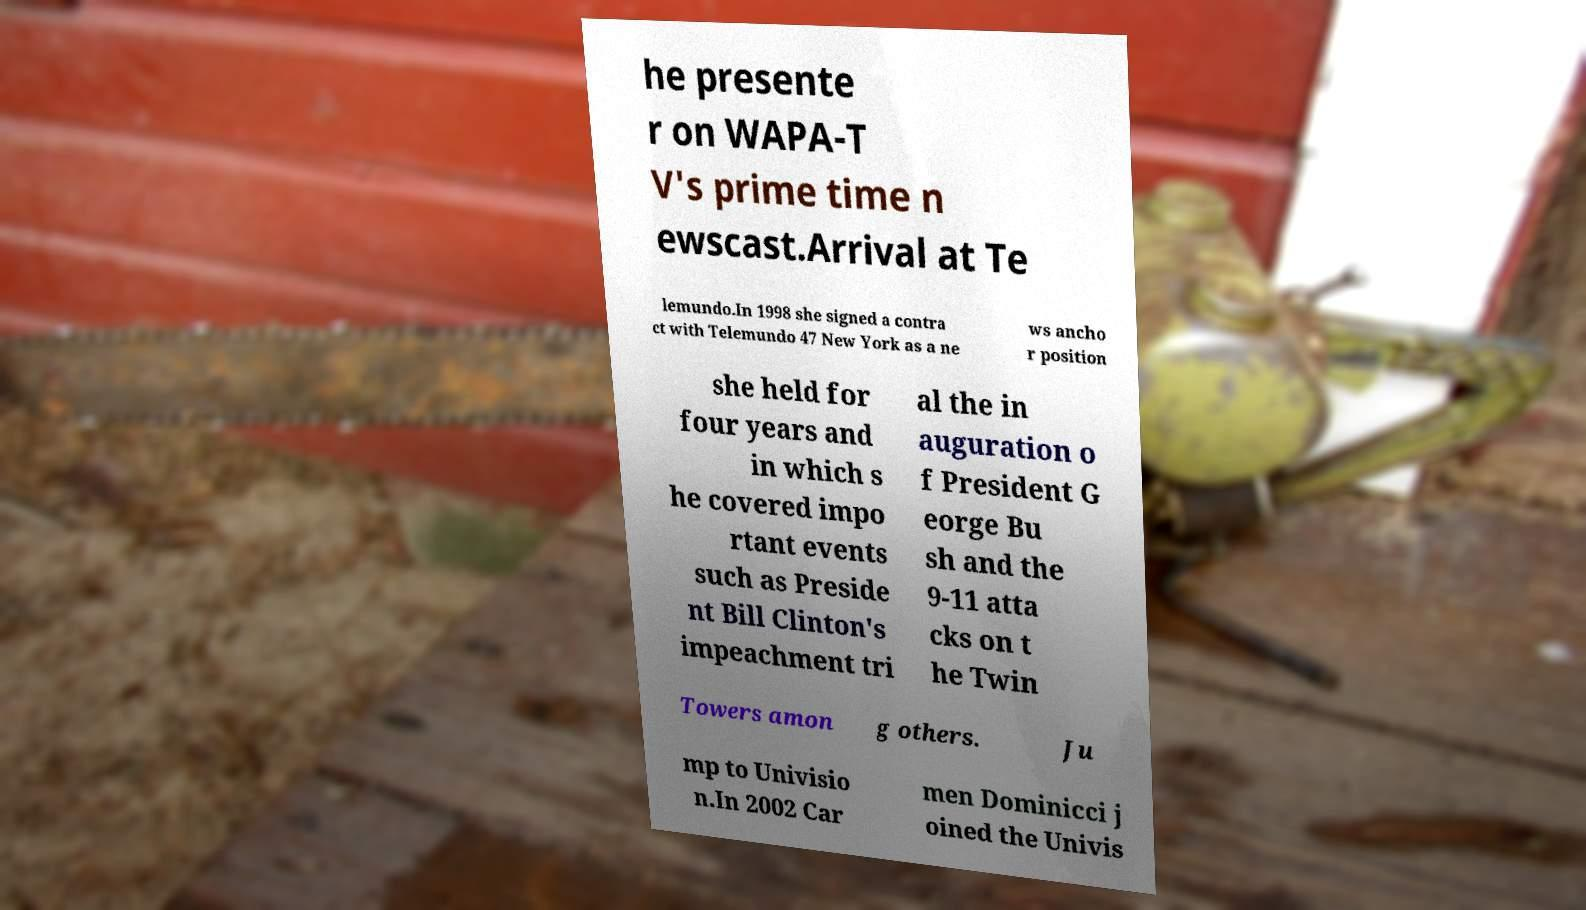I need the written content from this picture converted into text. Can you do that? he presente r on WAPA-T V's prime time n ewscast.Arrival at Te lemundo.In 1998 she signed a contra ct with Telemundo 47 New York as a ne ws ancho r position she held for four years and in which s he covered impo rtant events such as Preside nt Bill Clinton's impeachment tri al the in auguration o f President G eorge Bu sh and the 9-11 atta cks on t he Twin Towers amon g others. Ju mp to Univisio n.In 2002 Car men Dominicci j oined the Univis 